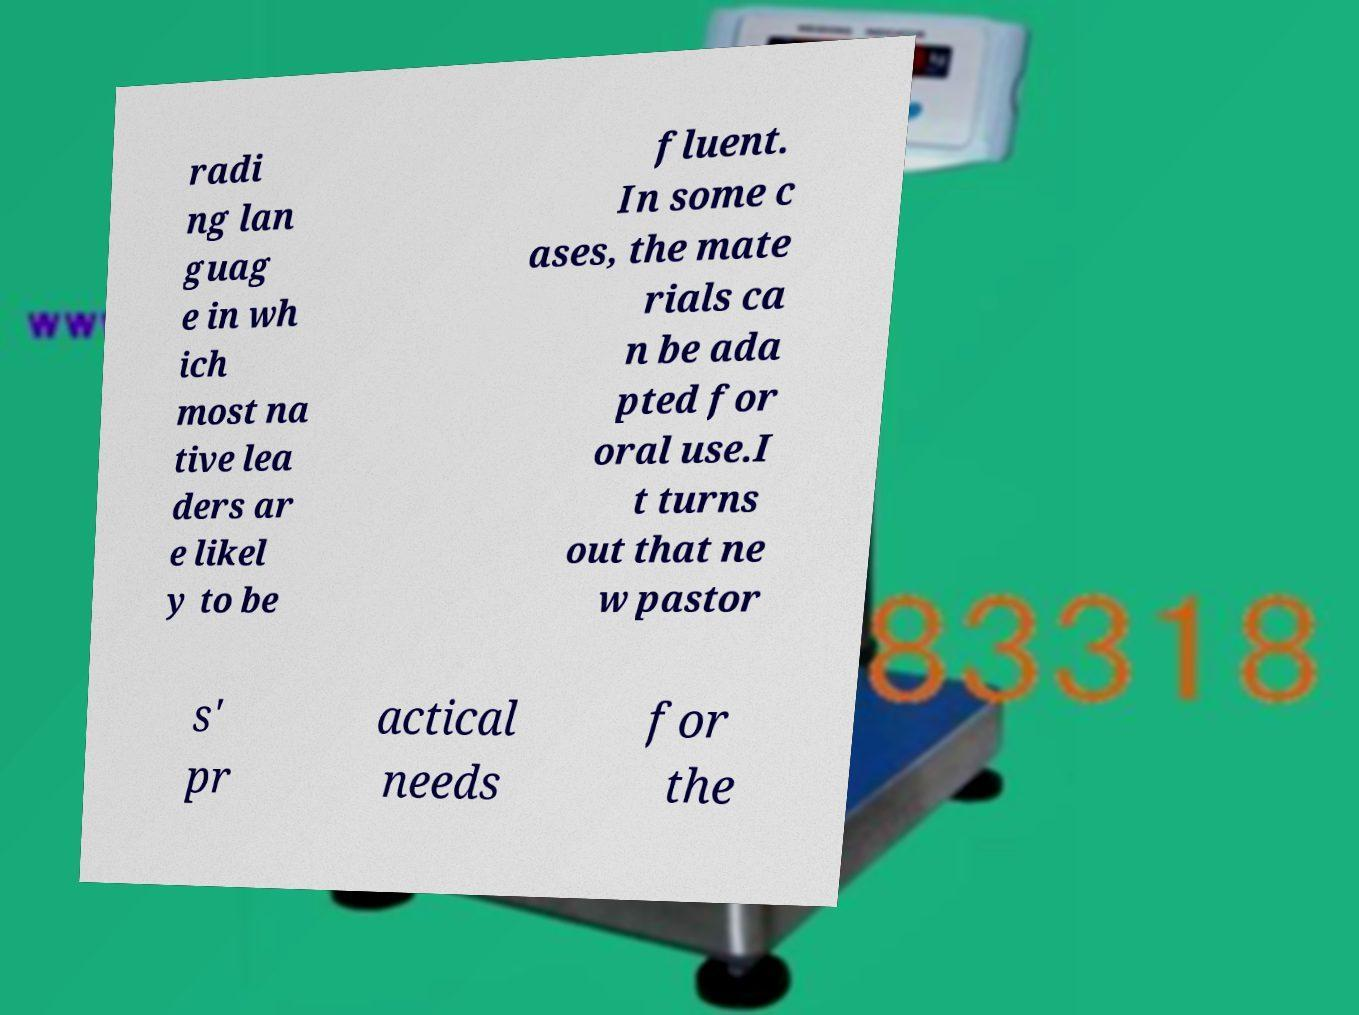Can you accurately transcribe the text from the provided image for me? radi ng lan guag e in wh ich most na tive lea ders ar e likel y to be fluent. In some c ases, the mate rials ca n be ada pted for oral use.I t turns out that ne w pastor s' pr actical needs for the 